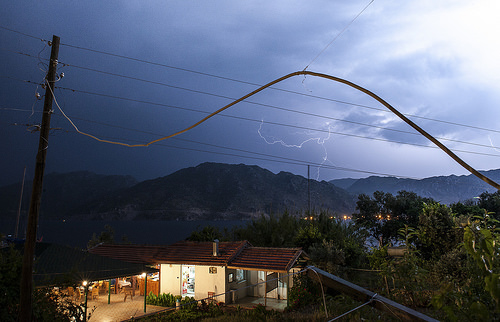<image>
Is the mountain behind the telephone pole? Yes. From this viewpoint, the mountain is positioned behind the telephone pole, with the telephone pole partially or fully occluding the mountain. 